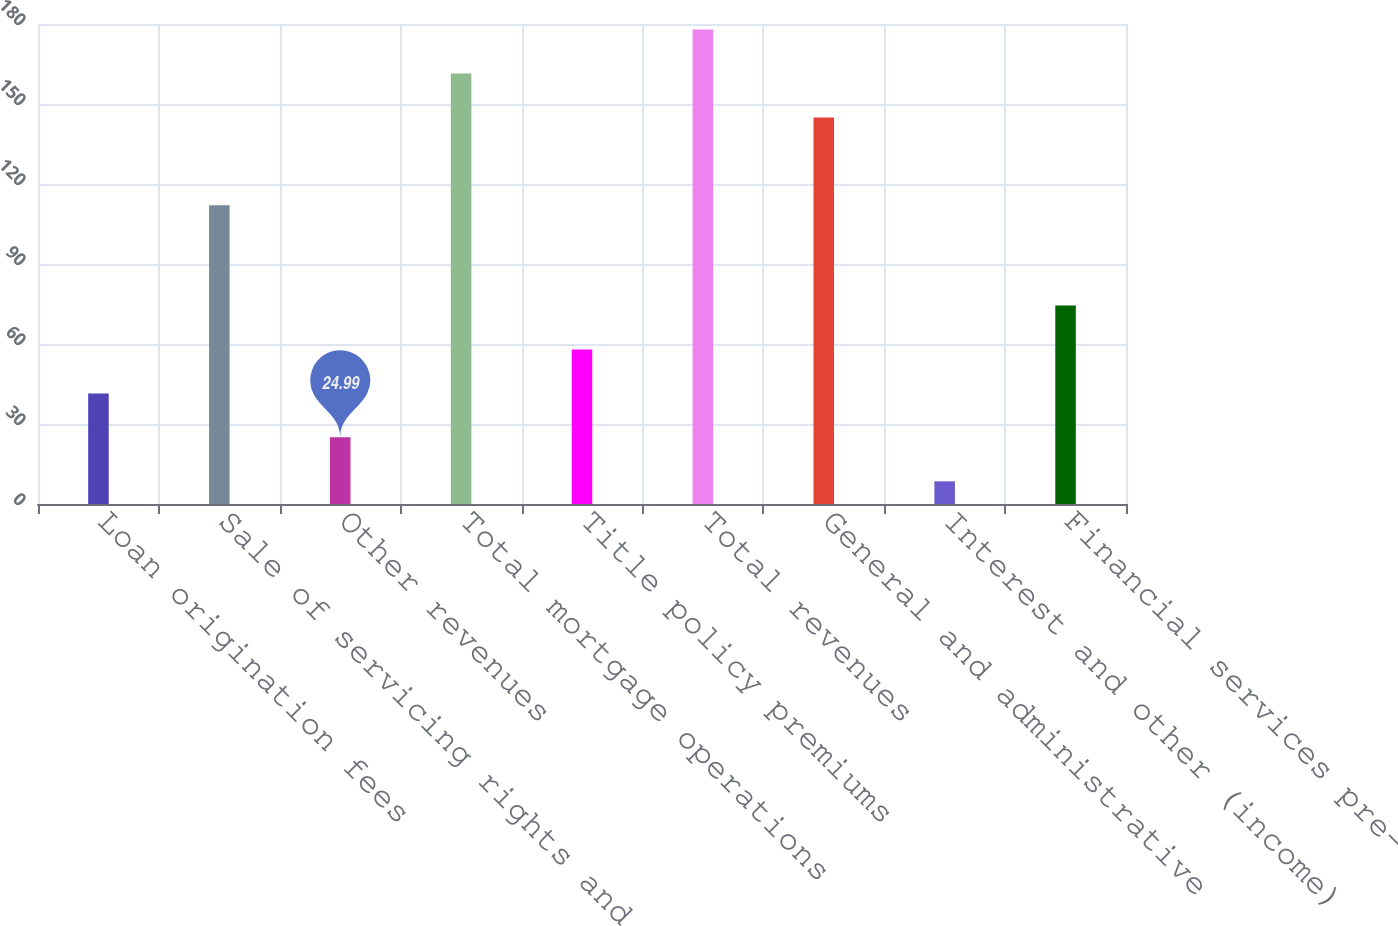Convert chart to OTSL. <chart><loc_0><loc_0><loc_500><loc_500><bar_chart><fcel>Loan origination fees<fcel>Sale of servicing rights and<fcel>Other revenues<fcel>Total mortgage operations<fcel>Title policy premiums<fcel>Total revenues<fcel>General and administrative<fcel>Interest and other (income)<fcel>Financial services pre-tax<nl><fcel>41.48<fcel>112<fcel>24.99<fcel>161.47<fcel>57.97<fcel>177.96<fcel>144.98<fcel>8.5<fcel>74.46<nl></chart> 